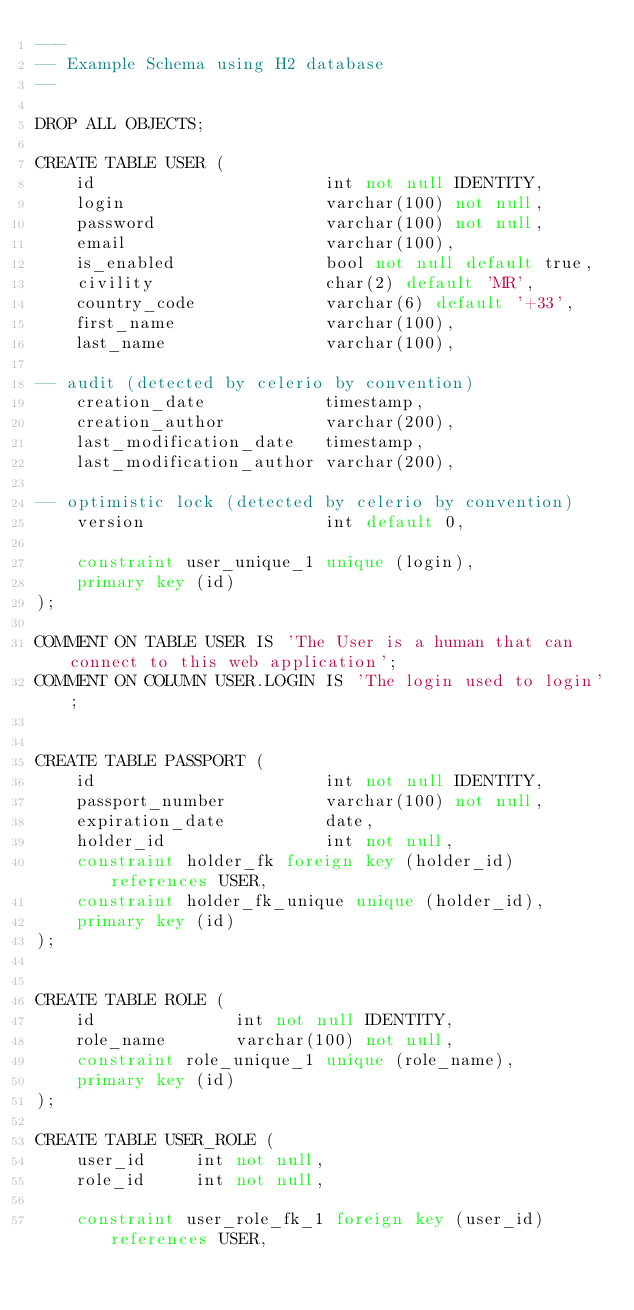<code> <loc_0><loc_0><loc_500><loc_500><_SQL_>---
-- Example Schema using H2 database
--

DROP ALL OBJECTS;

CREATE TABLE USER (
    id                       int not null IDENTITY,
    login                    varchar(100) not null,
    password                 varchar(100) not null,
    email                    varchar(100),
    is_enabled               bool not null default true,
    civility                 char(2) default 'MR',
    country_code             varchar(6) default '+33',
    first_name               varchar(100),
    last_name                varchar(100),

-- audit (detected by celerio by convention)
    creation_date            timestamp,
    creation_author          varchar(200),
    last_modification_date   timestamp,
    last_modification_author varchar(200),

-- optimistic lock (detected by celerio by convention)
    version                  int default 0,

    constraint user_unique_1 unique (login),
    primary key (id)
);

COMMENT ON TABLE USER IS 'The User is a human that can connect to this web application';
COMMENT ON COLUMN USER.LOGIN IS 'The login used to login';


CREATE TABLE PASSPORT (
    id                       int not null IDENTITY,
    passport_number          varchar(100) not null,
    expiration_date          date,
    holder_id                int not null,
    constraint holder_fk foreign key (holder_id) references USER,
    constraint holder_fk_unique unique (holder_id),
    primary key (id)
);


CREATE TABLE ROLE (
    id              int not null IDENTITY,
    role_name       varchar(100) not null,
    constraint role_unique_1 unique (role_name),
    primary key (id)
);

CREATE TABLE USER_ROLE (
    user_id     int not null,
    role_id     int not null,

    constraint user_role_fk_1 foreign key (user_id) references USER,</code> 